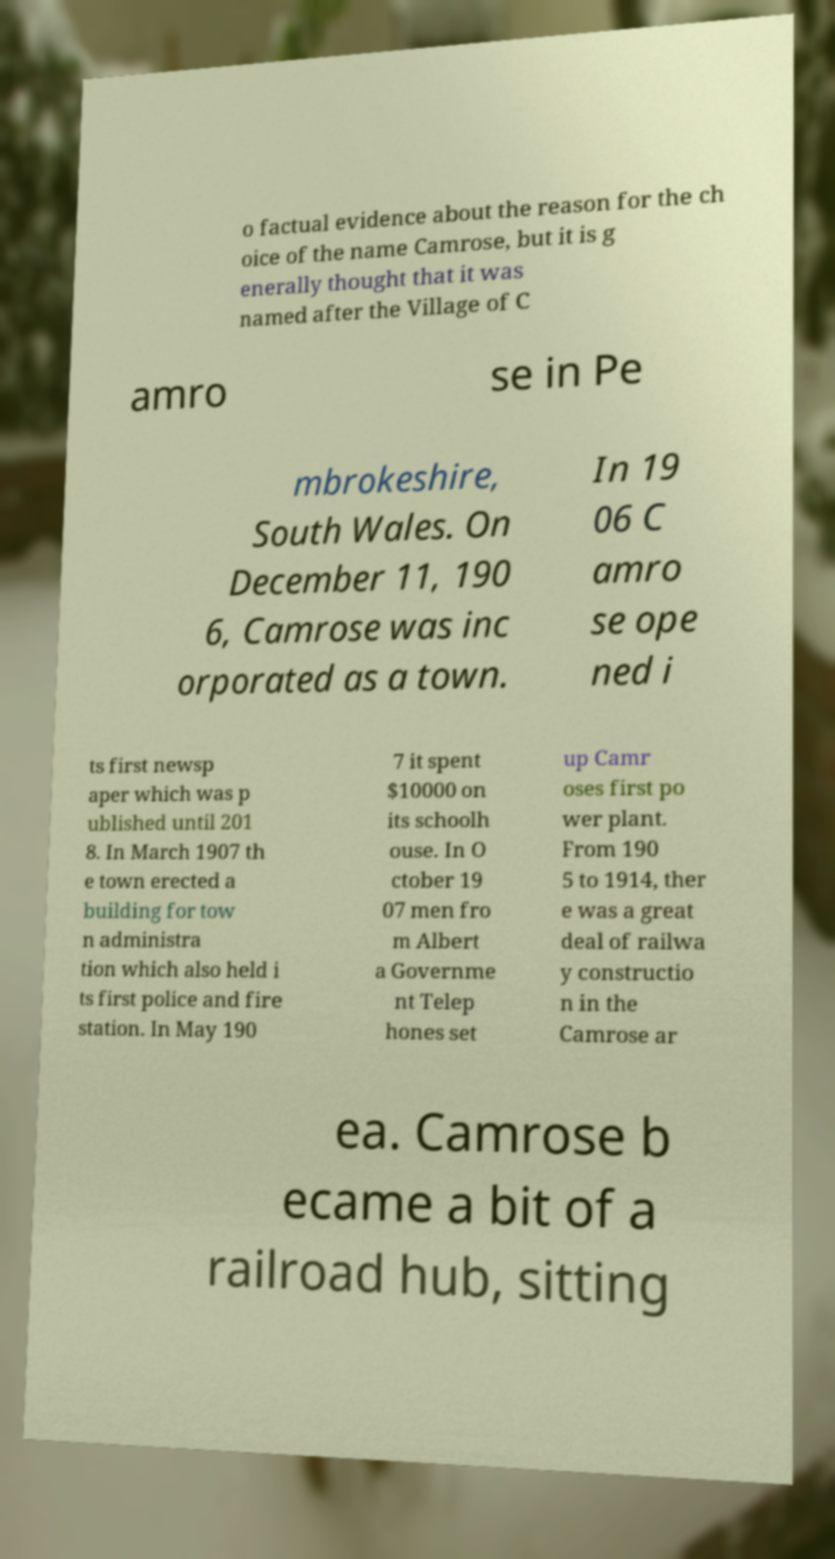Could you assist in decoding the text presented in this image and type it out clearly? o factual evidence about the reason for the ch oice of the name Camrose, but it is g enerally thought that it was named after the Village of C amro se in Pe mbrokeshire, South Wales. On December 11, 190 6, Camrose was inc orporated as a town. In 19 06 C amro se ope ned i ts first newsp aper which was p ublished until 201 8. In March 1907 th e town erected a building for tow n administra tion which also held i ts first police and fire station. In May 190 7 it spent $10000 on its schoolh ouse. In O ctober 19 07 men fro m Albert a Governme nt Telep hones set up Camr oses first po wer plant. From 190 5 to 1914, ther e was a great deal of railwa y constructio n in the Camrose ar ea. Camrose b ecame a bit of a railroad hub, sitting 